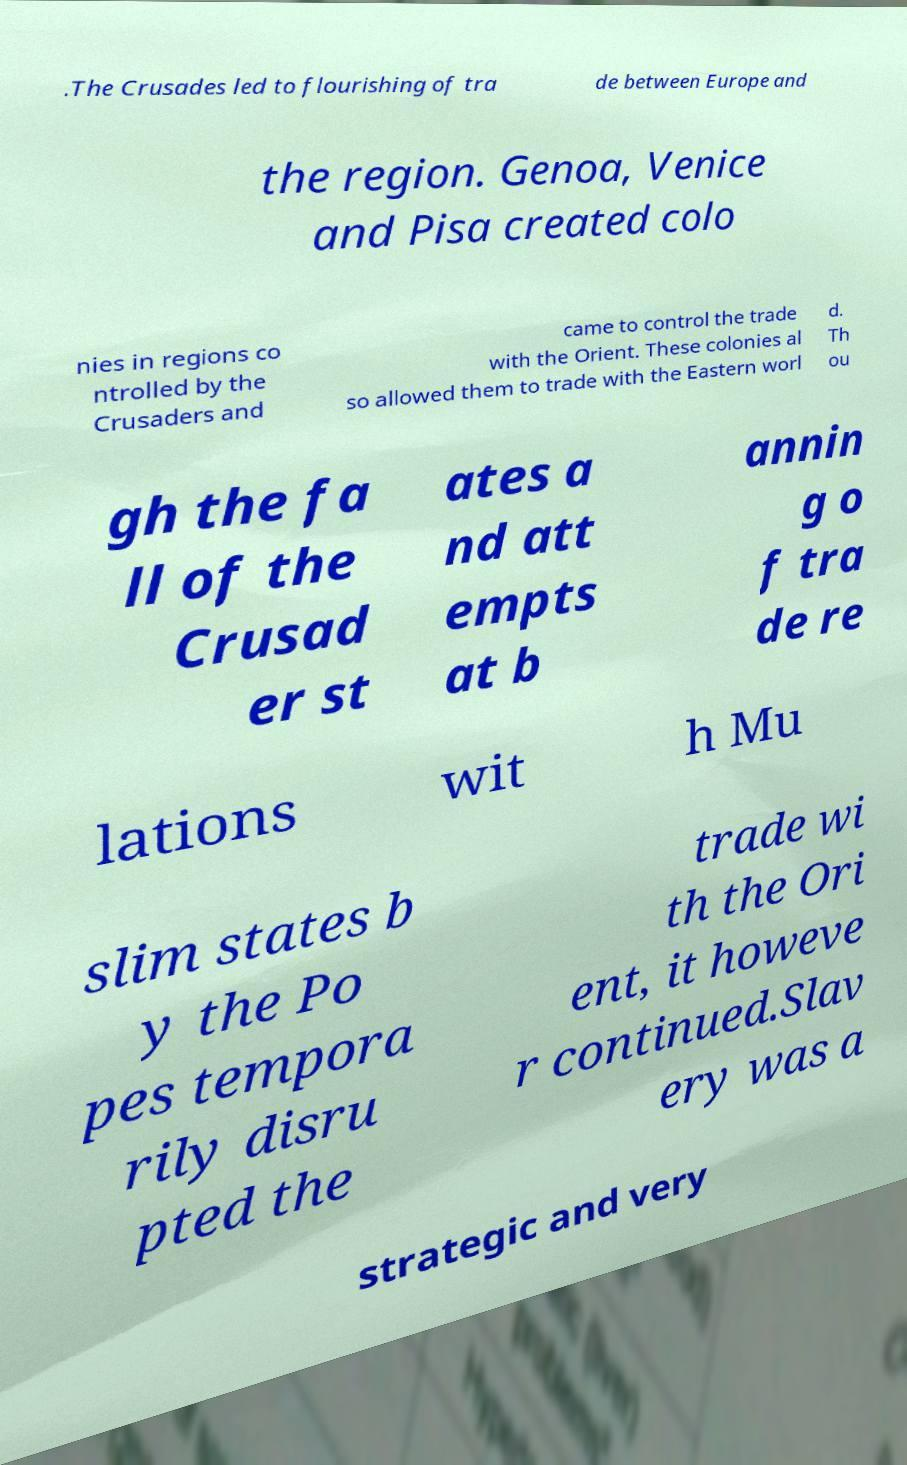Could you extract and type out the text from this image? .The Crusades led to flourishing of tra de between Europe and the region. Genoa, Venice and Pisa created colo nies in regions co ntrolled by the Crusaders and came to control the trade with the Orient. These colonies al so allowed them to trade with the Eastern worl d. Th ou gh the fa ll of the Crusad er st ates a nd att empts at b annin g o f tra de re lations wit h Mu slim states b y the Po pes tempora rily disru pted the trade wi th the Ori ent, it howeve r continued.Slav ery was a strategic and very 